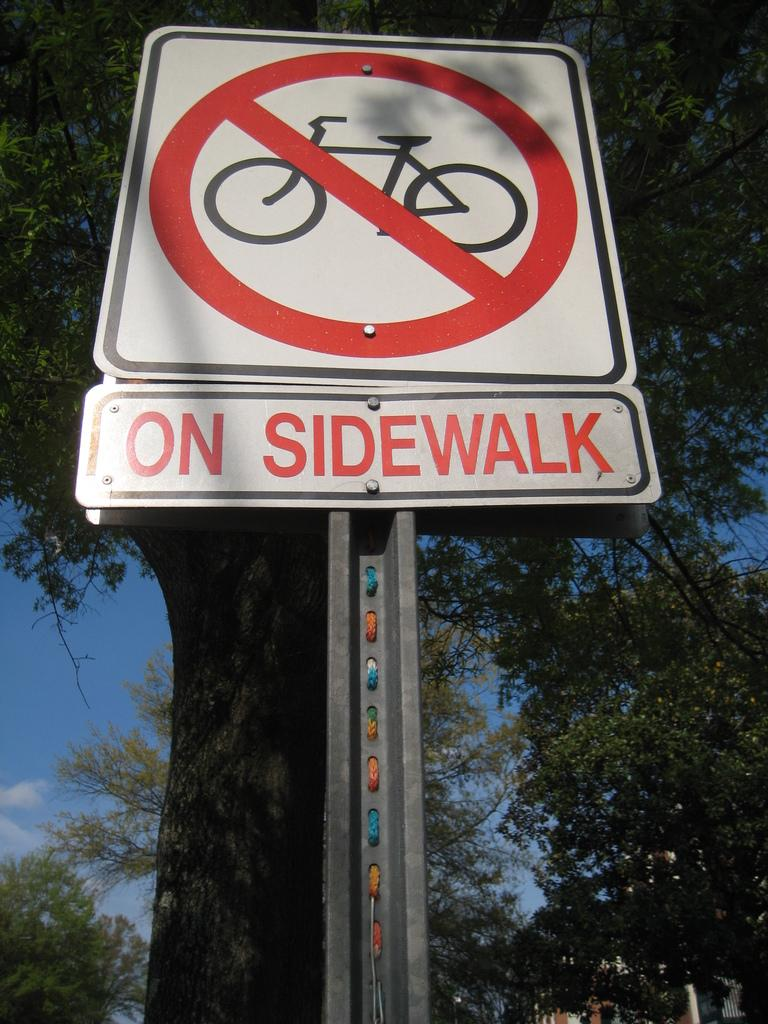<image>
Write a terse but informative summary of the picture. A sign indicates that there is to be no cycling 'on sidewalk' 